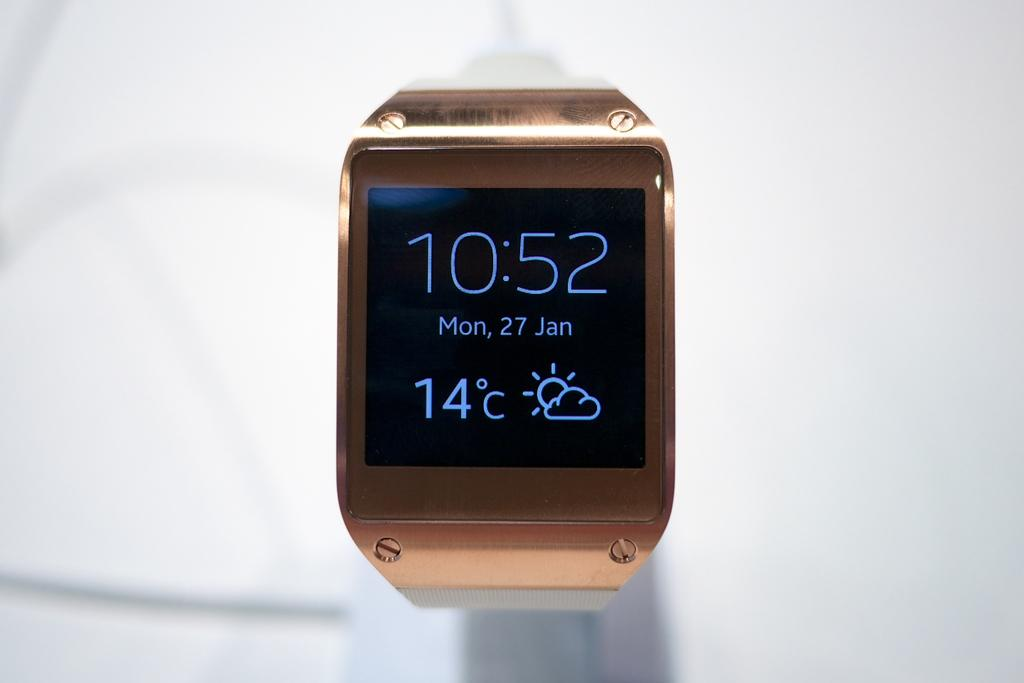<image>
Provide a brief description of the given image. A square faced watch with the time 10:52 showing on the face as well as the temperature and date. 